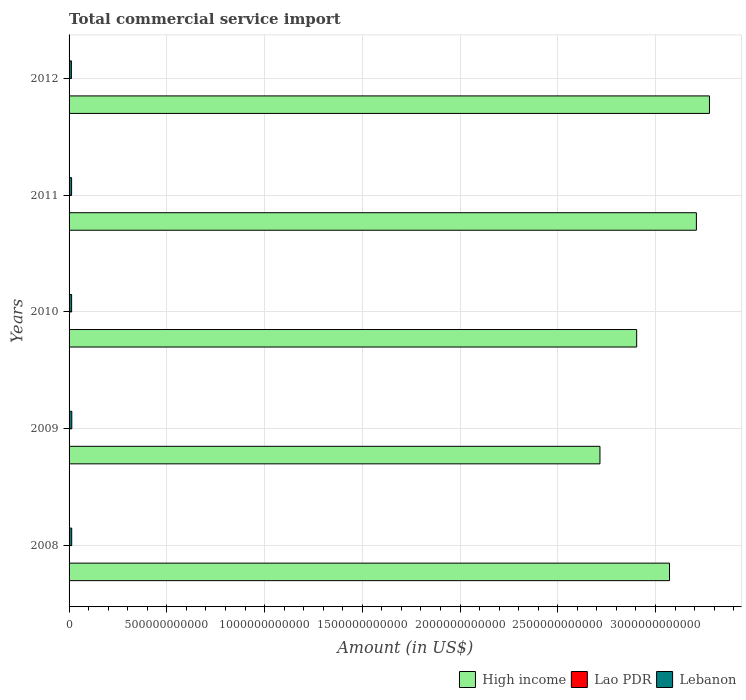Are the number of bars per tick equal to the number of legend labels?
Your answer should be compact. Yes. How many bars are there on the 4th tick from the top?
Provide a succinct answer. 3. What is the label of the 1st group of bars from the top?
Offer a terse response. 2012. In how many cases, is the number of bars for a given year not equal to the number of legend labels?
Provide a short and direct response. 0. What is the total commercial service import in Lao PDR in 2010?
Offer a very short reply. 2.58e+08. Across all years, what is the maximum total commercial service import in High income?
Your response must be concise. 3.28e+12. Across all years, what is the minimum total commercial service import in High income?
Your answer should be compact. 2.72e+12. In which year was the total commercial service import in High income minimum?
Give a very brief answer. 2009. What is the total total commercial service import in Lebanon in the graph?
Make the answer very short. 6.53e+1. What is the difference between the total commercial service import in Lao PDR in 2009 and that in 2012?
Keep it short and to the point. -2.03e+08. What is the difference between the total commercial service import in High income in 2010 and the total commercial service import in Lebanon in 2012?
Provide a short and direct response. 2.89e+12. What is the average total commercial service import in Lebanon per year?
Provide a short and direct response. 1.31e+1. In the year 2012, what is the difference between the total commercial service import in High income and total commercial service import in Lebanon?
Ensure brevity in your answer.  3.26e+12. What is the ratio of the total commercial service import in Lao PDR in 2010 to that in 2011?
Ensure brevity in your answer.  0.79. Is the total commercial service import in Lao PDR in 2008 less than that in 2009?
Provide a short and direct response. Yes. What is the difference between the highest and the second highest total commercial service import in Lao PDR?
Provide a short and direct response. 8.01e+06. What is the difference between the highest and the lowest total commercial service import in Lao PDR?
Your answer should be compact. 2.31e+08. What does the 2nd bar from the top in 2008 represents?
Ensure brevity in your answer.  Lao PDR. Is it the case that in every year, the sum of the total commercial service import in High income and total commercial service import in Lao PDR is greater than the total commercial service import in Lebanon?
Provide a short and direct response. Yes. Are all the bars in the graph horizontal?
Ensure brevity in your answer.  Yes. What is the difference between two consecutive major ticks on the X-axis?
Provide a succinct answer. 5.00e+11. Does the graph contain any zero values?
Keep it short and to the point. No. Does the graph contain grids?
Provide a succinct answer. Yes. How many legend labels are there?
Give a very brief answer. 3. What is the title of the graph?
Provide a succinct answer. Total commercial service import. What is the label or title of the X-axis?
Keep it short and to the point. Amount (in US$). What is the Amount (in US$) of High income in 2008?
Provide a succinct answer. 3.07e+12. What is the Amount (in US$) in Lao PDR in 2008?
Make the answer very short. 1.02e+08. What is the Amount (in US$) in Lebanon in 2008?
Give a very brief answer. 1.34e+1. What is the Amount (in US$) of High income in 2009?
Your answer should be compact. 2.72e+12. What is the Amount (in US$) of Lao PDR in 2009?
Offer a terse response. 1.30e+08. What is the Amount (in US$) in Lebanon in 2009?
Your answer should be very brief. 1.40e+1. What is the Amount (in US$) in High income in 2010?
Give a very brief answer. 2.90e+12. What is the Amount (in US$) of Lao PDR in 2010?
Give a very brief answer. 2.58e+08. What is the Amount (in US$) in Lebanon in 2010?
Make the answer very short. 1.30e+1. What is the Amount (in US$) of High income in 2011?
Make the answer very short. 3.21e+12. What is the Amount (in US$) of Lao PDR in 2011?
Your response must be concise. 3.25e+08. What is the Amount (in US$) in Lebanon in 2011?
Give a very brief answer. 1.29e+1. What is the Amount (in US$) of High income in 2012?
Give a very brief answer. 3.28e+12. What is the Amount (in US$) of Lao PDR in 2012?
Offer a terse response. 3.33e+08. What is the Amount (in US$) of Lebanon in 2012?
Your answer should be compact. 1.19e+1. Across all years, what is the maximum Amount (in US$) in High income?
Make the answer very short. 3.28e+12. Across all years, what is the maximum Amount (in US$) of Lao PDR?
Provide a short and direct response. 3.33e+08. Across all years, what is the maximum Amount (in US$) of Lebanon?
Your answer should be very brief. 1.40e+1. Across all years, what is the minimum Amount (in US$) of High income?
Make the answer very short. 2.72e+12. Across all years, what is the minimum Amount (in US$) of Lao PDR?
Your answer should be very brief. 1.02e+08. Across all years, what is the minimum Amount (in US$) in Lebanon?
Make the answer very short. 1.19e+1. What is the total Amount (in US$) of High income in the graph?
Ensure brevity in your answer.  1.52e+13. What is the total Amount (in US$) of Lao PDR in the graph?
Your answer should be very brief. 1.15e+09. What is the total Amount (in US$) in Lebanon in the graph?
Keep it short and to the point. 6.53e+1. What is the difference between the Amount (in US$) in High income in 2008 and that in 2009?
Ensure brevity in your answer.  3.56e+11. What is the difference between the Amount (in US$) of Lao PDR in 2008 and that in 2009?
Keep it short and to the point. -2.76e+07. What is the difference between the Amount (in US$) in Lebanon in 2008 and that in 2009?
Keep it short and to the point. -5.83e+08. What is the difference between the Amount (in US$) of High income in 2008 and that in 2010?
Make the answer very short. 1.68e+11. What is the difference between the Amount (in US$) in Lao PDR in 2008 and that in 2010?
Your response must be concise. -1.55e+08. What is the difference between the Amount (in US$) in Lebanon in 2008 and that in 2010?
Offer a terse response. 4.30e+08. What is the difference between the Amount (in US$) of High income in 2008 and that in 2011?
Keep it short and to the point. -1.38e+11. What is the difference between the Amount (in US$) of Lao PDR in 2008 and that in 2011?
Your answer should be very brief. -2.23e+08. What is the difference between the Amount (in US$) of Lebanon in 2008 and that in 2011?
Your response must be concise. 4.96e+08. What is the difference between the Amount (in US$) in High income in 2008 and that in 2012?
Make the answer very short. -2.05e+11. What is the difference between the Amount (in US$) in Lao PDR in 2008 and that in 2012?
Offer a terse response. -2.31e+08. What is the difference between the Amount (in US$) of Lebanon in 2008 and that in 2012?
Your answer should be very brief. 1.58e+09. What is the difference between the Amount (in US$) in High income in 2009 and that in 2010?
Your answer should be compact. -1.88e+11. What is the difference between the Amount (in US$) in Lao PDR in 2009 and that in 2010?
Make the answer very short. -1.28e+08. What is the difference between the Amount (in US$) of Lebanon in 2009 and that in 2010?
Provide a succinct answer. 1.01e+09. What is the difference between the Amount (in US$) in High income in 2009 and that in 2011?
Ensure brevity in your answer.  -4.93e+11. What is the difference between the Amount (in US$) in Lao PDR in 2009 and that in 2011?
Your answer should be compact. -1.95e+08. What is the difference between the Amount (in US$) in Lebanon in 2009 and that in 2011?
Keep it short and to the point. 1.08e+09. What is the difference between the Amount (in US$) of High income in 2009 and that in 2012?
Offer a very short reply. -5.60e+11. What is the difference between the Amount (in US$) in Lao PDR in 2009 and that in 2012?
Give a very brief answer. -2.03e+08. What is the difference between the Amount (in US$) of Lebanon in 2009 and that in 2012?
Your answer should be very brief. 2.17e+09. What is the difference between the Amount (in US$) in High income in 2010 and that in 2011?
Ensure brevity in your answer.  -3.06e+11. What is the difference between the Amount (in US$) of Lao PDR in 2010 and that in 2011?
Ensure brevity in your answer.  -6.75e+07. What is the difference between the Amount (in US$) in Lebanon in 2010 and that in 2011?
Provide a succinct answer. 6.61e+07. What is the difference between the Amount (in US$) of High income in 2010 and that in 2012?
Your response must be concise. -3.72e+11. What is the difference between the Amount (in US$) of Lao PDR in 2010 and that in 2012?
Give a very brief answer. -7.55e+07. What is the difference between the Amount (in US$) of Lebanon in 2010 and that in 2012?
Your answer should be compact. 1.15e+09. What is the difference between the Amount (in US$) in High income in 2011 and that in 2012?
Provide a short and direct response. -6.69e+1. What is the difference between the Amount (in US$) in Lao PDR in 2011 and that in 2012?
Your answer should be compact. -8.01e+06. What is the difference between the Amount (in US$) in Lebanon in 2011 and that in 2012?
Your answer should be very brief. 1.09e+09. What is the difference between the Amount (in US$) of High income in 2008 and the Amount (in US$) of Lao PDR in 2009?
Provide a short and direct response. 3.07e+12. What is the difference between the Amount (in US$) in High income in 2008 and the Amount (in US$) in Lebanon in 2009?
Your response must be concise. 3.06e+12. What is the difference between the Amount (in US$) of Lao PDR in 2008 and the Amount (in US$) of Lebanon in 2009?
Offer a terse response. -1.39e+1. What is the difference between the Amount (in US$) in High income in 2008 and the Amount (in US$) in Lao PDR in 2010?
Ensure brevity in your answer.  3.07e+12. What is the difference between the Amount (in US$) in High income in 2008 and the Amount (in US$) in Lebanon in 2010?
Keep it short and to the point. 3.06e+12. What is the difference between the Amount (in US$) in Lao PDR in 2008 and the Amount (in US$) in Lebanon in 2010?
Give a very brief answer. -1.29e+1. What is the difference between the Amount (in US$) in High income in 2008 and the Amount (in US$) in Lao PDR in 2011?
Offer a terse response. 3.07e+12. What is the difference between the Amount (in US$) of High income in 2008 and the Amount (in US$) of Lebanon in 2011?
Make the answer very short. 3.06e+12. What is the difference between the Amount (in US$) in Lao PDR in 2008 and the Amount (in US$) in Lebanon in 2011?
Provide a short and direct response. -1.28e+1. What is the difference between the Amount (in US$) in High income in 2008 and the Amount (in US$) in Lao PDR in 2012?
Your answer should be compact. 3.07e+12. What is the difference between the Amount (in US$) in High income in 2008 and the Amount (in US$) in Lebanon in 2012?
Your answer should be very brief. 3.06e+12. What is the difference between the Amount (in US$) of Lao PDR in 2008 and the Amount (in US$) of Lebanon in 2012?
Ensure brevity in your answer.  -1.18e+1. What is the difference between the Amount (in US$) of High income in 2009 and the Amount (in US$) of Lao PDR in 2010?
Provide a short and direct response. 2.72e+12. What is the difference between the Amount (in US$) of High income in 2009 and the Amount (in US$) of Lebanon in 2010?
Offer a very short reply. 2.70e+12. What is the difference between the Amount (in US$) in Lao PDR in 2009 and the Amount (in US$) in Lebanon in 2010?
Your answer should be compact. -1.29e+1. What is the difference between the Amount (in US$) of High income in 2009 and the Amount (in US$) of Lao PDR in 2011?
Keep it short and to the point. 2.72e+12. What is the difference between the Amount (in US$) in High income in 2009 and the Amount (in US$) in Lebanon in 2011?
Make the answer very short. 2.70e+12. What is the difference between the Amount (in US$) in Lao PDR in 2009 and the Amount (in US$) in Lebanon in 2011?
Your response must be concise. -1.28e+1. What is the difference between the Amount (in US$) in High income in 2009 and the Amount (in US$) in Lao PDR in 2012?
Ensure brevity in your answer.  2.72e+12. What is the difference between the Amount (in US$) of High income in 2009 and the Amount (in US$) of Lebanon in 2012?
Give a very brief answer. 2.70e+12. What is the difference between the Amount (in US$) in Lao PDR in 2009 and the Amount (in US$) in Lebanon in 2012?
Your answer should be very brief. -1.17e+1. What is the difference between the Amount (in US$) of High income in 2010 and the Amount (in US$) of Lao PDR in 2011?
Make the answer very short. 2.90e+12. What is the difference between the Amount (in US$) of High income in 2010 and the Amount (in US$) of Lebanon in 2011?
Give a very brief answer. 2.89e+12. What is the difference between the Amount (in US$) in Lao PDR in 2010 and the Amount (in US$) in Lebanon in 2011?
Your answer should be very brief. -1.27e+1. What is the difference between the Amount (in US$) in High income in 2010 and the Amount (in US$) in Lao PDR in 2012?
Offer a terse response. 2.90e+12. What is the difference between the Amount (in US$) in High income in 2010 and the Amount (in US$) in Lebanon in 2012?
Keep it short and to the point. 2.89e+12. What is the difference between the Amount (in US$) in Lao PDR in 2010 and the Amount (in US$) in Lebanon in 2012?
Keep it short and to the point. -1.16e+1. What is the difference between the Amount (in US$) in High income in 2011 and the Amount (in US$) in Lao PDR in 2012?
Your answer should be compact. 3.21e+12. What is the difference between the Amount (in US$) of High income in 2011 and the Amount (in US$) of Lebanon in 2012?
Provide a short and direct response. 3.20e+12. What is the difference between the Amount (in US$) of Lao PDR in 2011 and the Amount (in US$) of Lebanon in 2012?
Make the answer very short. -1.15e+1. What is the average Amount (in US$) in High income per year?
Make the answer very short. 3.04e+12. What is the average Amount (in US$) in Lao PDR per year?
Offer a very short reply. 2.30e+08. What is the average Amount (in US$) in Lebanon per year?
Ensure brevity in your answer.  1.31e+1. In the year 2008, what is the difference between the Amount (in US$) of High income and Amount (in US$) of Lao PDR?
Keep it short and to the point. 3.07e+12. In the year 2008, what is the difference between the Amount (in US$) in High income and Amount (in US$) in Lebanon?
Your response must be concise. 3.06e+12. In the year 2008, what is the difference between the Amount (in US$) in Lao PDR and Amount (in US$) in Lebanon?
Keep it short and to the point. -1.33e+1. In the year 2009, what is the difference between the Amount (in US$) of High income and Amount (in US$) of Lao PDR?
Offer a terse response. 2.72e+12. In the year 2009, what is the difference between the Amount (in US$) of High income and Amount (in US$) of Lebanon?
Provide a short and direct response. 2.70e+12. In the year 2009, what is the difference between the Amount (in US$) in Lao PDR and Amount (in US$) in Lebanon?
Give a very brief answer. -1.39e+1. In the year 2010, what is the difference between the Amount (in US$) of High income and Amount (in US$) of Lao PDR?
Your answer should be very brief. 2.90e+12. In the year 2010, what is the difference between the Amount (in US$) of High income and Amount (in US$) of Lebanon?
Offer a very short reply. 2.89e+12. In the year 2010, what is the difference between the Amount (in US$) in Lao PDR and Amount (in US$) in Lebanon?
Keep it short and to the point. -1.28e+1. In the year 2011, what is the difference between the Amount (in US$) of High income and Amount (in US$) of Lao PDR?
Your response must be concise. 3.21e+12. In the year 2011, what is the difference between the Amount (in US$) of High income and Amount (in US$) of Lebanon?
Offer a very short reply. 3.20e+12. In the year 2011, what is the difference between the Amount (in US$) of Lao PDR and Amount (in US$) of Lebanon?
Keep it short and to the point. -1.26e+1. In the year 2012, what is the difference between the Amount (in US$) of High income and Amount (in US$) of Lao PDR?
Your answer should be compact. 3.28e+12. In the year 2012, what is the difference between the Amount (in US$) of High income and Amount (in US$) of Lebanon?
Keep it short and to the point. 3.26e+12. In the year 2012, what is the difference between the Amount (in US$) of Lao PDR and Amount (in US$) of Lebanon?
Your answer should be very brief. -1.15e+1. What is the ratio of the Amount (in US$) of High income in 2008 to that in 2009?
Make the answer very short. 1.13. What is the ratio of the Amount (in US$) of Lao PDR in 2008 to that in 2009?
Keep it short and to the point. 0.79. What is the ratio of the Amount (in US$) in Lebanon in 2008 to that in 2009?
Offer a terse response. 0.96. What is the ratio of the Amount (in US$) in High income in 2008 to that in 2010?
Your response must be concise. 1.06. What is the ratio of the Amount (in US$) in Lao PDR in 2008 to that in 2010?
Give a very brief answer. 0.4. What is the ratio of the Amount (in US$) of Lebanon in 2008 to that in 2010?
Offer a terse response. 1.03. What is the ratio of the Amount (in US$) of High income in 2008 to that in 2011?
Give a very brief answer. 0.96. What is the ratio of the Amount (in US$) in Lao PDR in 2008 to that in 2011?
Provide a short and direct response. 0.31. What is the ratio of the Amount (in US$) in Lebanon in 2008 to that in 2011?
Provide a succinct answer. 1.04. What is the ratio of the Amount (in US$) of High income in 2008 to that in 2012?
Your answer should be compact. 0.94. What is the ratio of the Amount (in US$) of Lao PDR in 2008 to that in 2012?
Keep it short and to the point. 0.31. What is the ratio of the Amount (in US$) in Lebanon in 2008 to that in 2012?
Give a very brief answer. 1.13. What is the ratio of the Amount (in US$) of High income in 2009 to that in 2010?
Keep it short and to the point. 0.94. What is the ratio of the Amount (in US$) of Lao PDR in 2009 to that in 2010?
Provide a succinct answer. 0.5. What is the ratio of the Amount (in US$) in Lebanon in 2009 to that in 2010?
Your response must be concise. 1.08. What is the ratio of the Amount (in US$) in High income in 2009 to that in 2011?
Offer a terse response. 0.85. What is the ratio of the Amount (in US$) in Lao PDR in 2009 to that in 2011?
Offer a very short reply. 0.4. What is the ratio of the Amount (in US$) of Lebanon in 2009 to that in 2011?
Provide a short and direct response. 1.08. What is the ratio of the Amount (in US$) in High income in 2009 to that in 2012?
Offer a very short reply. 0.83. What is the ratio of the Amount (in US$) in Lao PDR in 2009 to that in 2012?
Provide a succinct answer. 0.39. What is the ratio of the Amount (in US$) in Lebanon in 2009 to that in 2012?
Provide a succinct answer. 1.18. What is the ratio of the Amount (in US$) of High income in 2010 to that in 2011?
Give a very brief answer. 0.9. What is the ratio of the Amount (in US$) of Lao PDR in 2010 to that in 2011?
Your answer should be very brief. 0.79. What is the ratio of the Amount (in US$) of High income in 2010 to that in 2012?
Provide a short and direct response. 0.89. What is the ratio of the Amount (in US$) of Lao PDR in 2010 to that in 2012?
Your answer should be compact. 0.77. What is the ratio of the Amount (in US$) in Lebanon in 2010 to that in 2012?
Keep it short and to the point. 1.1. What is the ratio of the Amount (in US$) of High income in 2011 to that in 2012?
Give a very brief answer. 0.98. What is the ratio of the Amount (in US$) in Lao PDR in 2011 to that in 2012?
Your answer should be very brief. 0.98. What is the ratio of the Amount (in US$) of Lebanon in 2011 to that in 2012?
Keep it short and to the point. 1.09. What is the difference between the highest and the second highest Amount (in US$) in High income?
Your answer should be compact. 6.69e+1. What is the difference between the highest and the second highest Amount (in US$) in Lao PDR?
Your answer should be compact. 8.01e+06. What is the difference between the highest and the second highest Amount (in US$) in Lebanon?
Ensure brevity in your answer.  5.83e+08. What is the difference between the highest and the lowest Amount (in US$) in High income?
Give a very brief answer. 5.60e+11. What is the difference between the highest and the lowest Amount (in US$) of Lao PDR?
Ensure brevity in your answer.  2.31e+08. What is the difference between the highest and the lowest Amount (in US$) in Lebanon?
Your answer should be compact. 2.17e+09. 